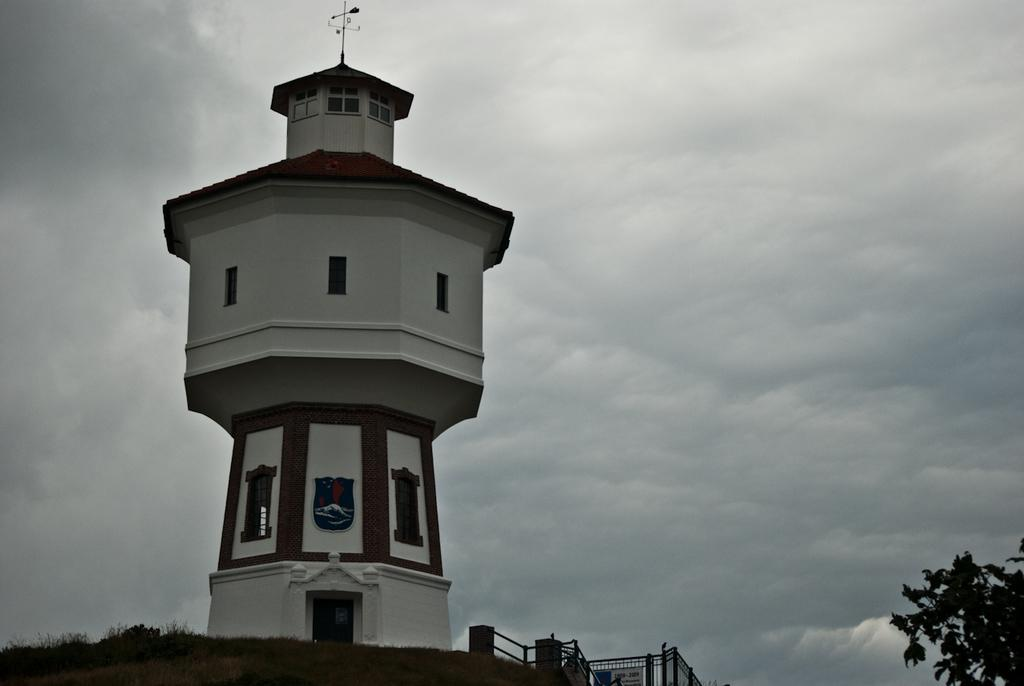What type of structure is present in the image? There is a building in the image. What colors can be seen on the building? The building has white and brown colors. What celestial bodies are visible in the background of the image? There are planets visible in the background. How would you describe the color of the sky in the image? The sky is white and gray in color. What type of harbor can be seen near the building in the image? There is no harbor present in the image; it only features a building and planets in the background. What process is taking place on the coast in the image? There is no coast or process visible in the image. 